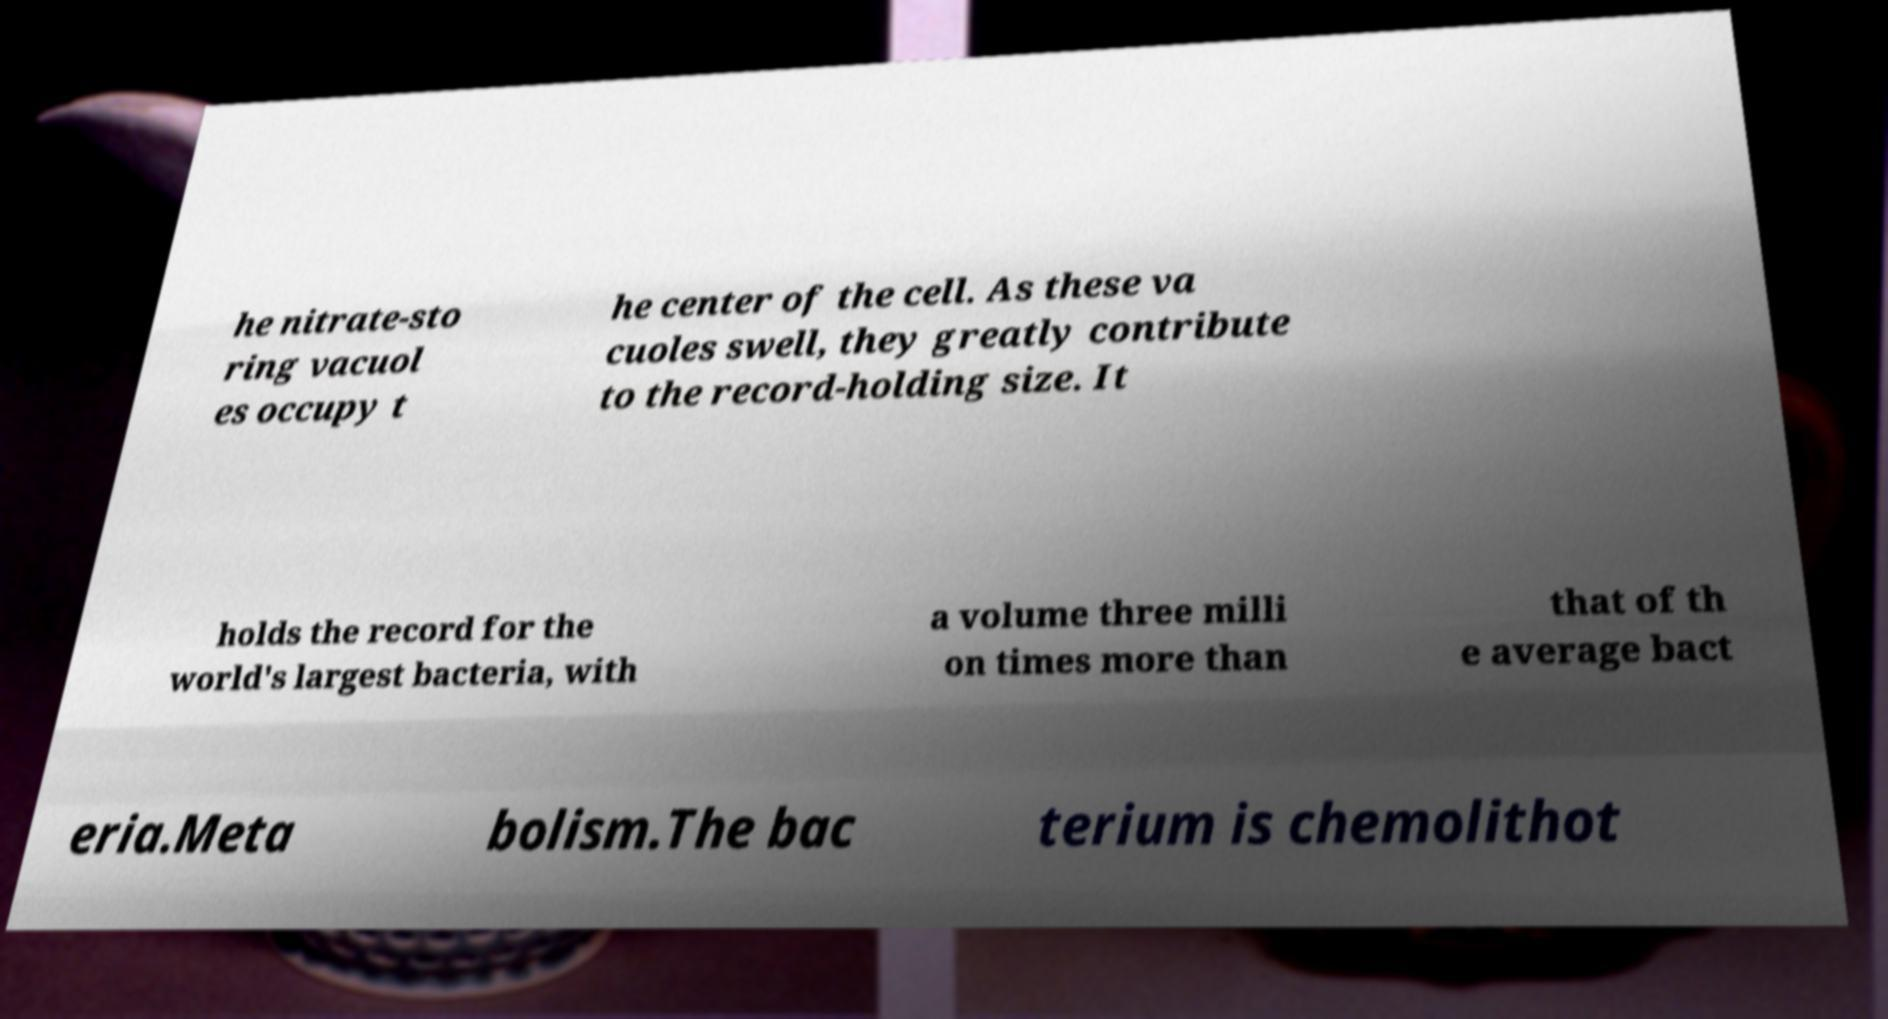What messages or text are displayed in this image? I need them in a readable, typed format. he nitrate-sto ring vacuol es occupy t he center of the cell. As these va cuoles swell, they greatly contribute to the record-holding size. It holds the record for the world's largest bacteria, with a volume three milli on times more than that of th e average bact eria.Meta bolism.The bac terium is chemolithot 